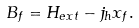Convert formula to latex. <formula><loc_0><loc_0><loc_500><loc_500>B _ { f } = H _ { e x t } - j _ { h } x _ { f } .</formula> 